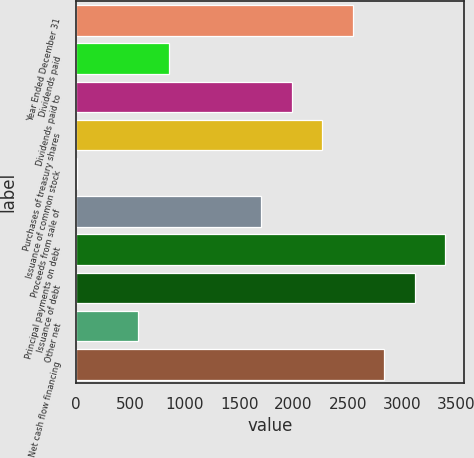Convert chart to OTSL. <chart><loc_0><loc_0><loc_500><loc_500><bar_chart><fcel>Year Ended December 31<fcel>Dividends paid<fcel>Dividends paid to<fcel>Purchases of treasury shares<fcel>Issuance of common stock<fcel>Proceeds from sale of<fcel>Principal payments on debt<fcel>Issuance of debt<fcel>Other net<fcel>Net cash flow financing<nl><fcel>2549.2<fcel>852.4<fcel>1983.6<fcel>2266.4<fcel>4<fcel>1700.8<fcel>3397.6<fcel>3114.8<fcel>569.6<fcel>2832<nl></chart> 